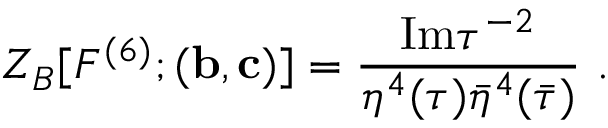Convert formula to latex. <formula><loc_0><loc_0><loc_500><loc_500>Z _ { B } [ F ^ { ( 6 ) } ; ( { b } , { c } ) ] = \frac { I m \tau ^ { - 2 } } { \eta ^ { 4 } ( \tau ) \bar { \eta } ^ { 4 } ( \bar { \tau } ) } \ .</formula> 